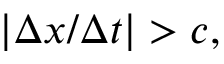<formula> <loc_0><loc_0><loc_500><loc_500>| \Delta x / \Delta t | > c ,</formula> 